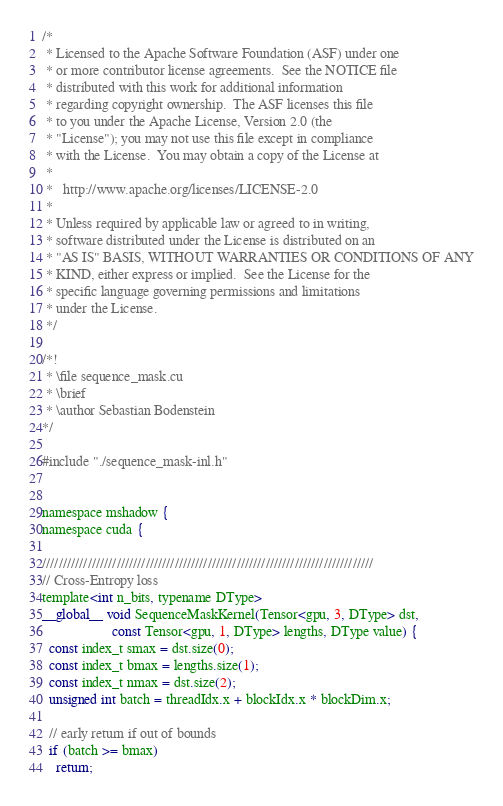Convert code to text. <code><loc_0><loc_0><loc_500><loc_500><_Cuda_>/*
 * Licensed to the Apache Software Foundation (ASF) under one
 * or more contributor license agreements.  See the NOTICE file
 * distributed with this work for additional information
 * regarding copyright ownership.  The ASF licenses this file
 * to you under the Apache License, Version 2.0 (the
 * "License"); you may not use this file except in compliance
 * with the License.  You may obtain a copy of the License at
 *
 *   http://www.apache.org/licenses/LICENSE-2.0
 *
 * Unless required by applicable law or agreed to in writing,
 * software distributed under the License is distributed on an
 * "AS IS" BASIS, WITHOUT WARRANTIES OR CONDITIONS OF ANY
 * KIND, either express or implied.  See the License for the
 * specific language governing permissions and limitations
 * under the License.
 */

/*!
 * \file sequence_mask.cu
 * \brief
 * \author Sebastian Bodenstein
*/

#include "./sequence_mask-inl.h"


namespace mshadow {
namespace cuda {

////////////////////////////////////////////////////////////////////////////////
// Cross-Entropy loss
template<int n_bits, typename DType>
__global__ void SequenceMaskKernel(Tensor<gpu, 3, DType> dst,
                    const Tensor<gpu, 1, DType> lengths, DType value) {
  const index_t smax = dst.size(0);
  const index_t bmax = lengths.size(1);
  const index_t nmax = dst.size(2);
  unsigned int batch = threadIdx.x + blockIdx.x * blockDim.x;

  // early return if out of bounds
  if (batch >= bmax)
    return;
</code> 